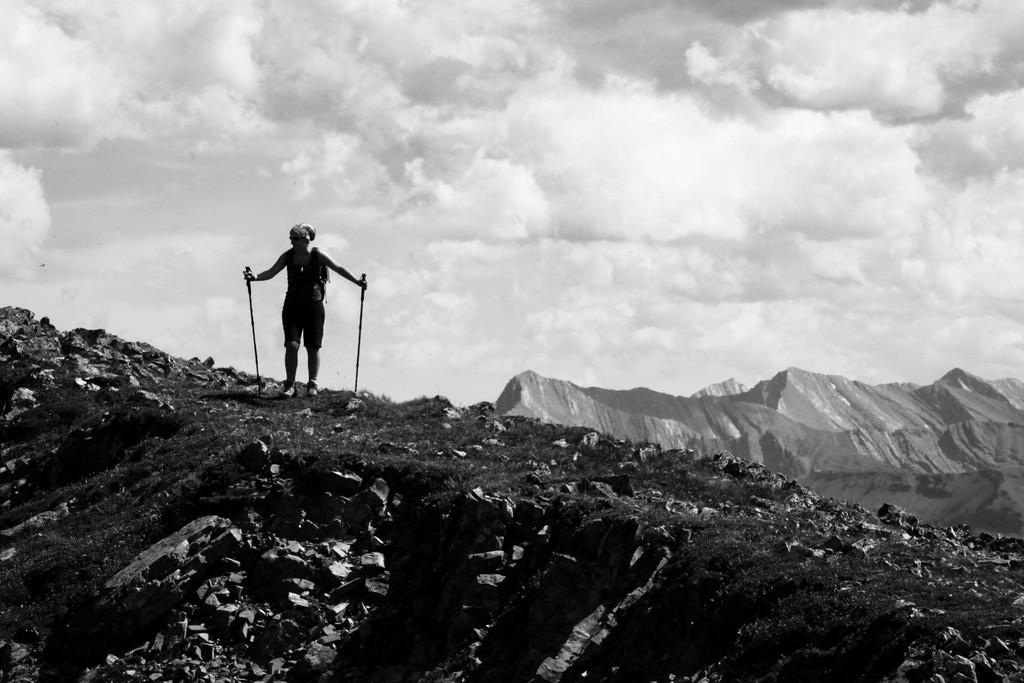Can you describe this image briefly? In the middle of the image we can see a person is standing and the person is holding sticks, in the background we can see hills and clouds, it is a black and white photography. 